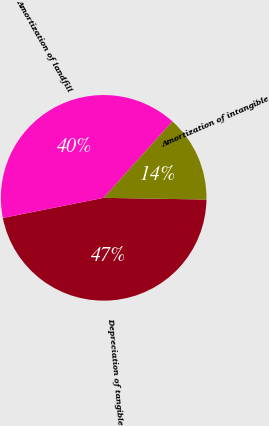Convert chart. <chart><loc_0><loc_0><loc_500><loc_500><pie_chart><fcel>Depreciation of tangible<fcel>Amortization of landfill<fcel>Amortization of intangible<nl><fcel>46.6%<fcel>39.79%<fcel>13.61%<nl></chart> 